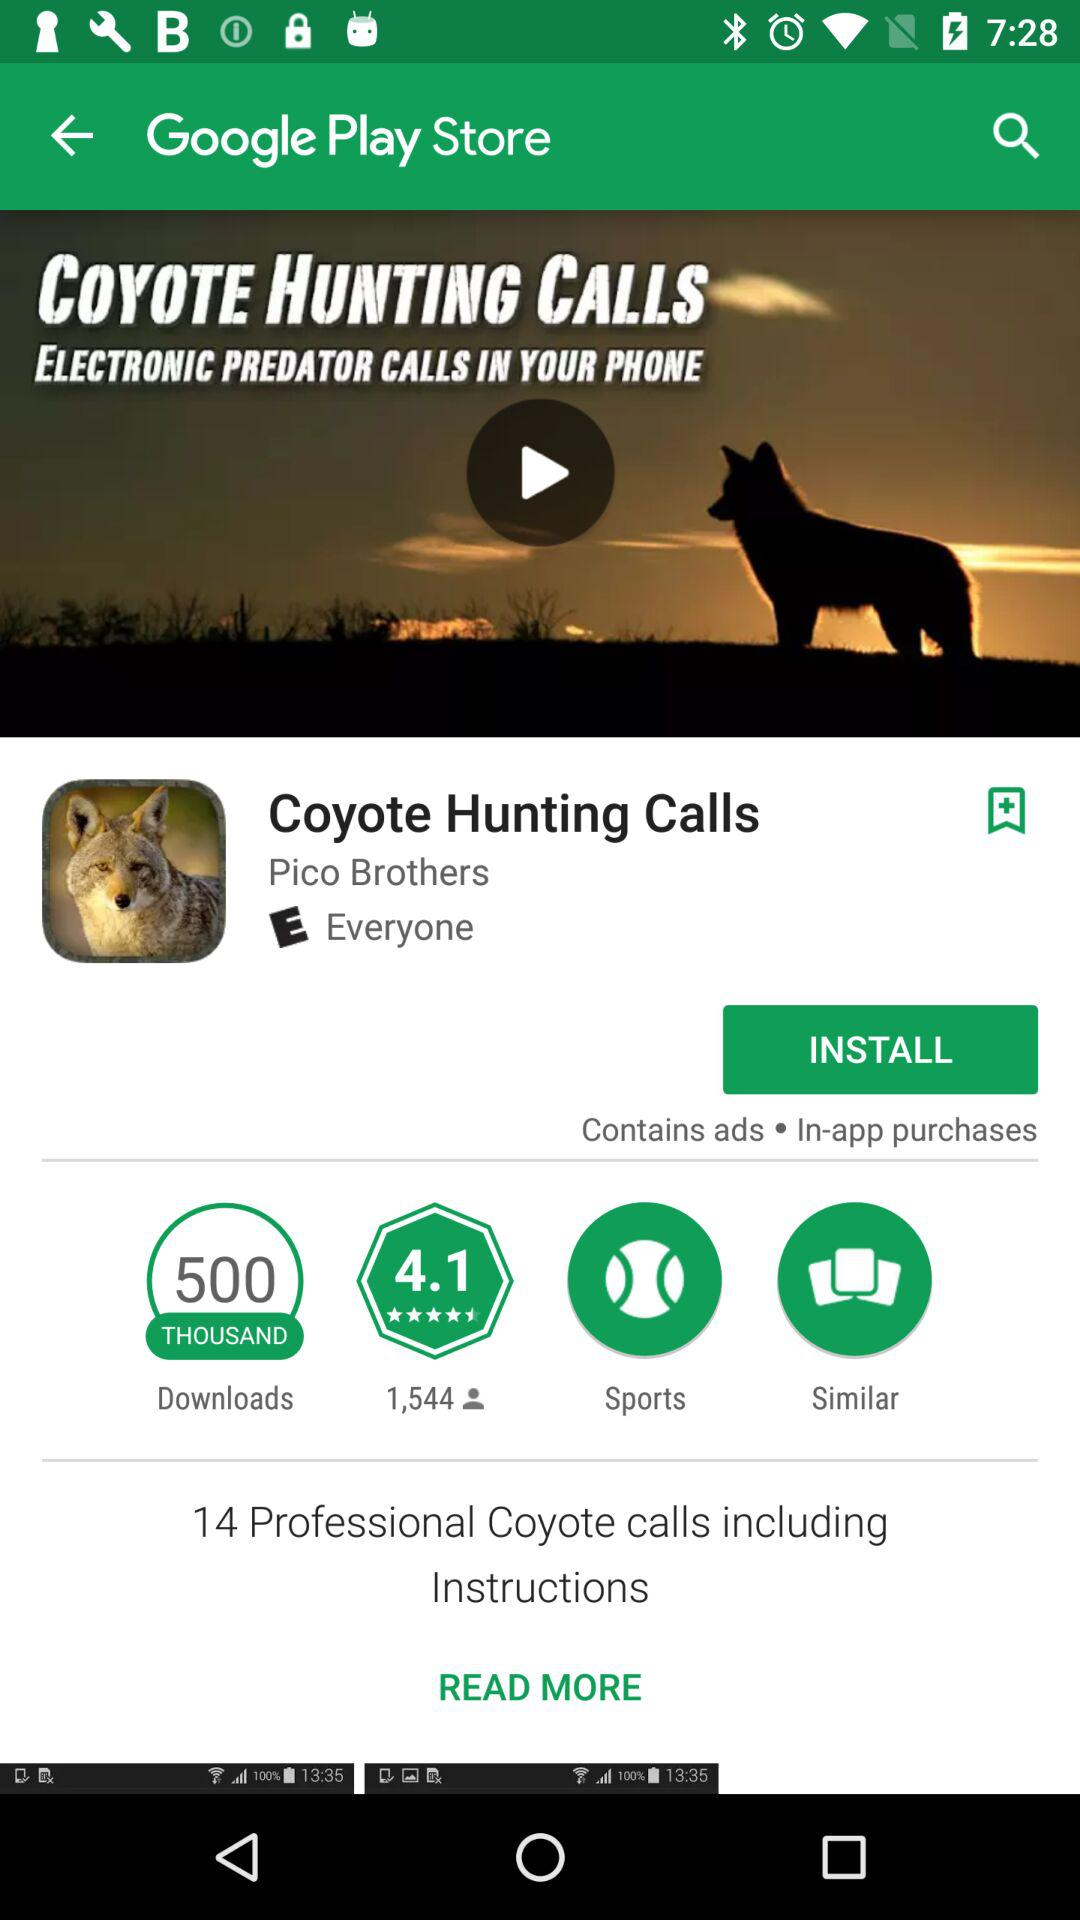What's the Nature of Application?
When the provided information is insufficient, respond with <no answer>. <no answer> 